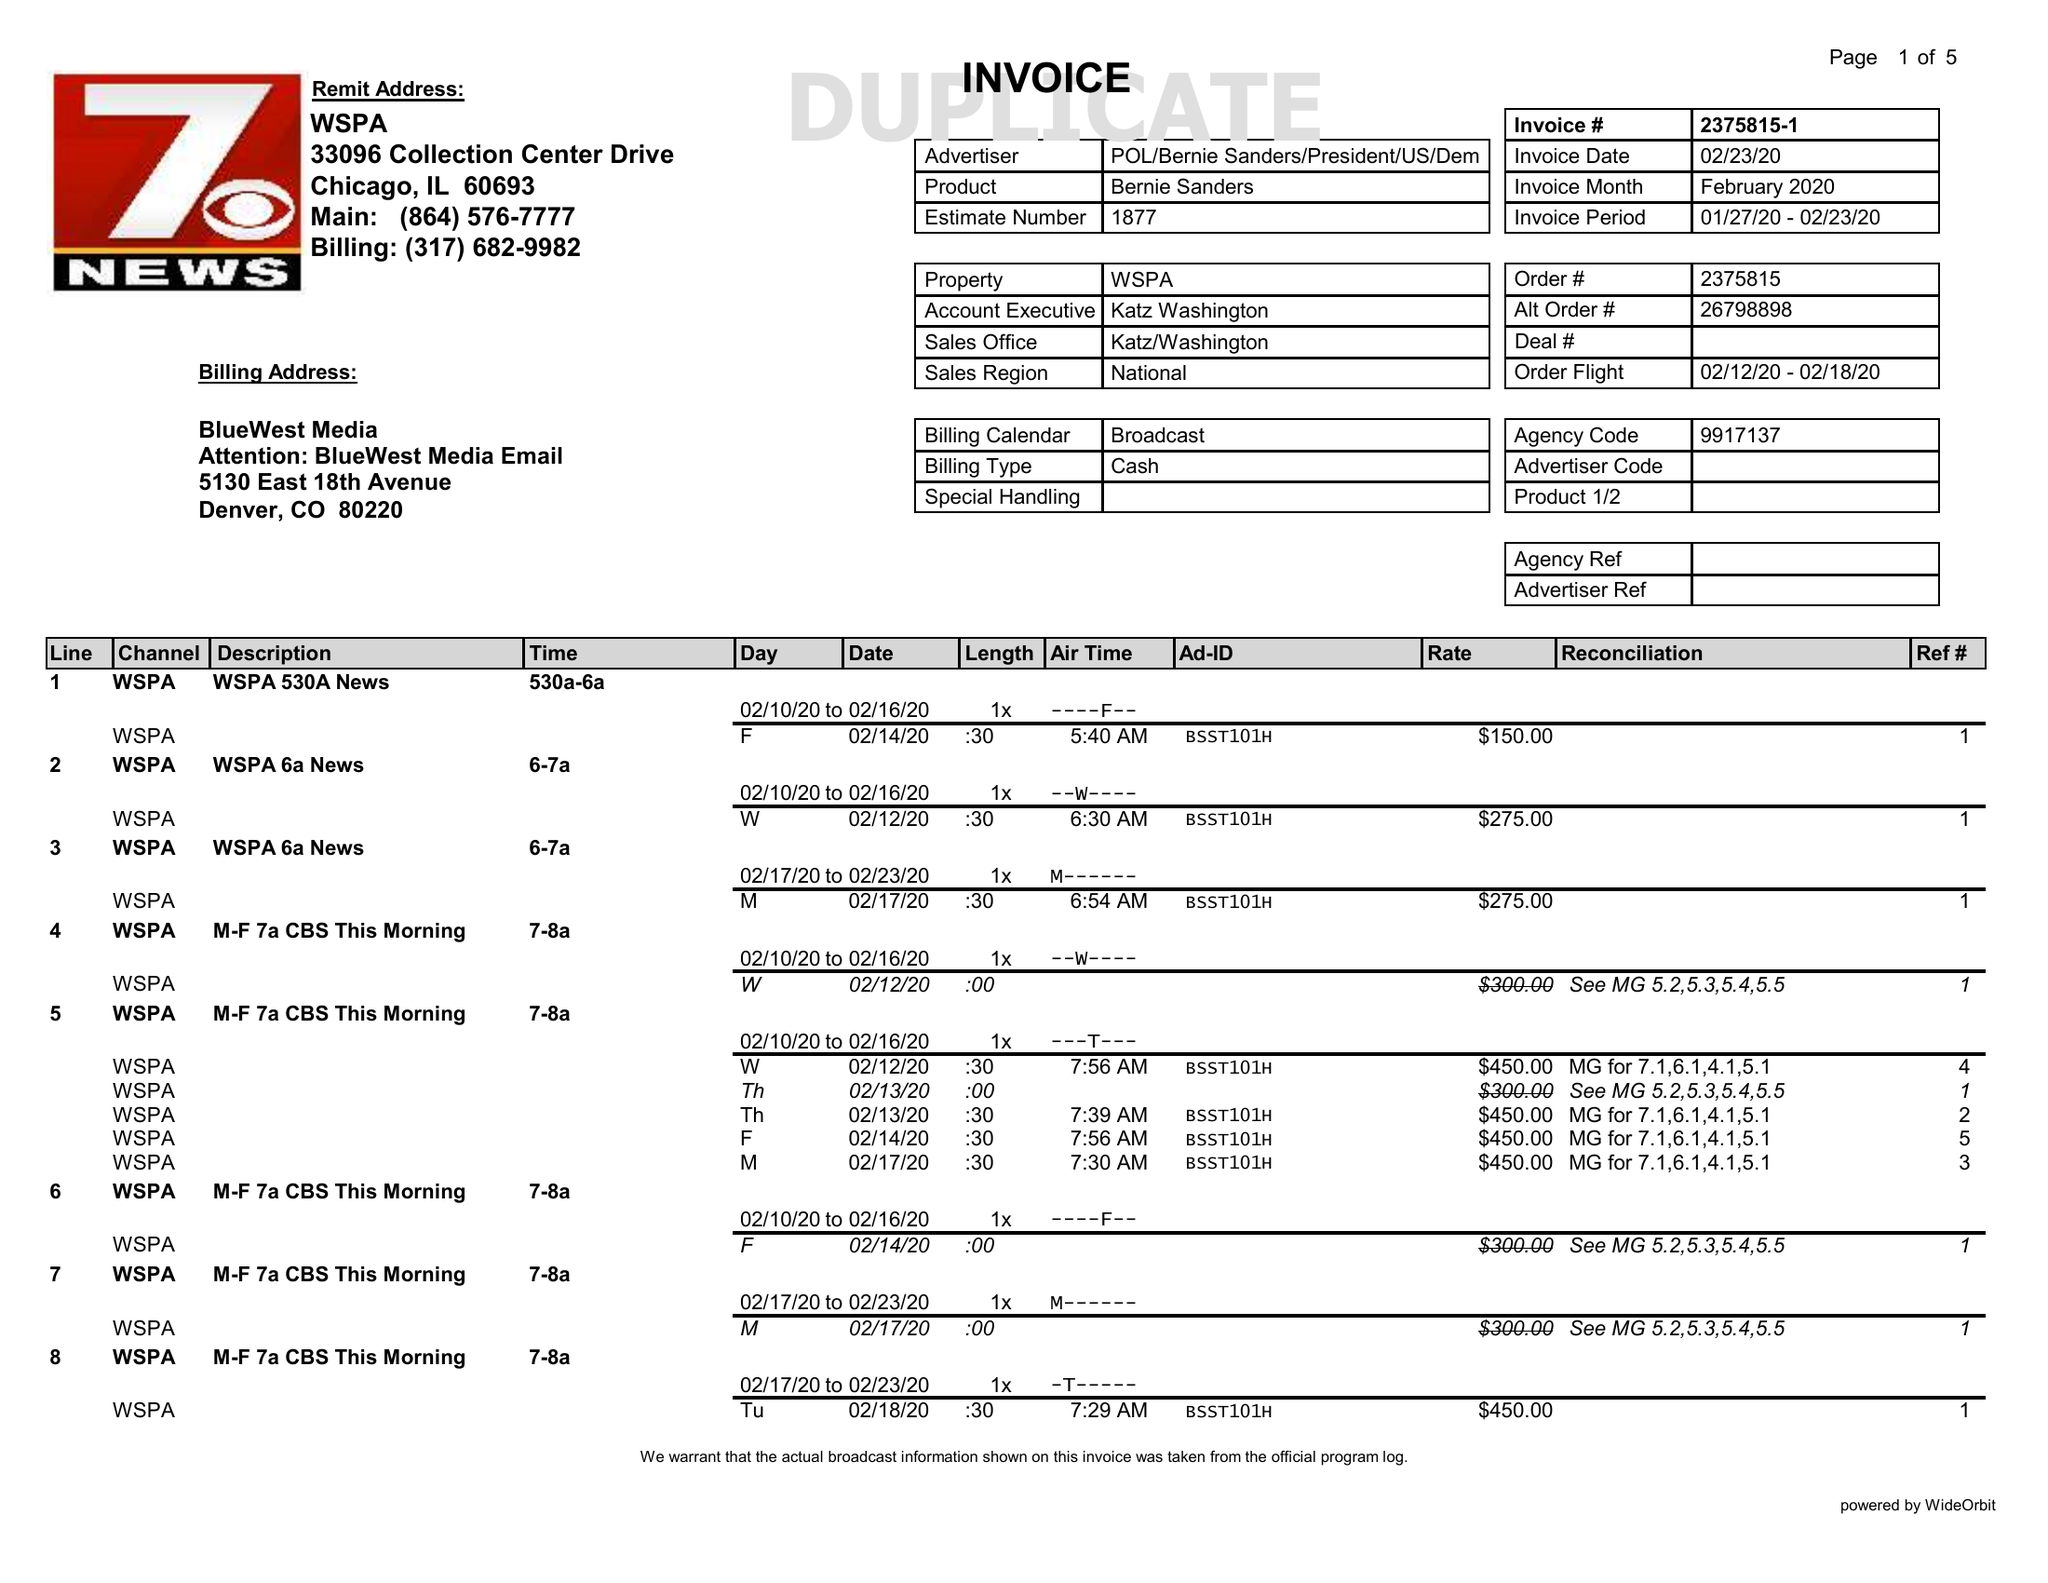What is the value for the gross_amount?
Answer the question using a single word or phrase. 18525.00 